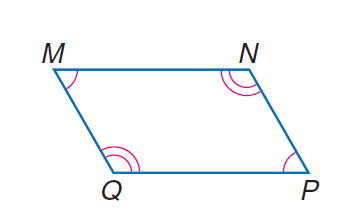Answer the mathemtical geometry problem and directly provide the correct option letter.
Question: parallelogram M N P Q with m \angle M = 10 x and m \angle N = 20 x, find \angle Q.
Choices: A: 30 B: 45 C: 60 D: 120 D 